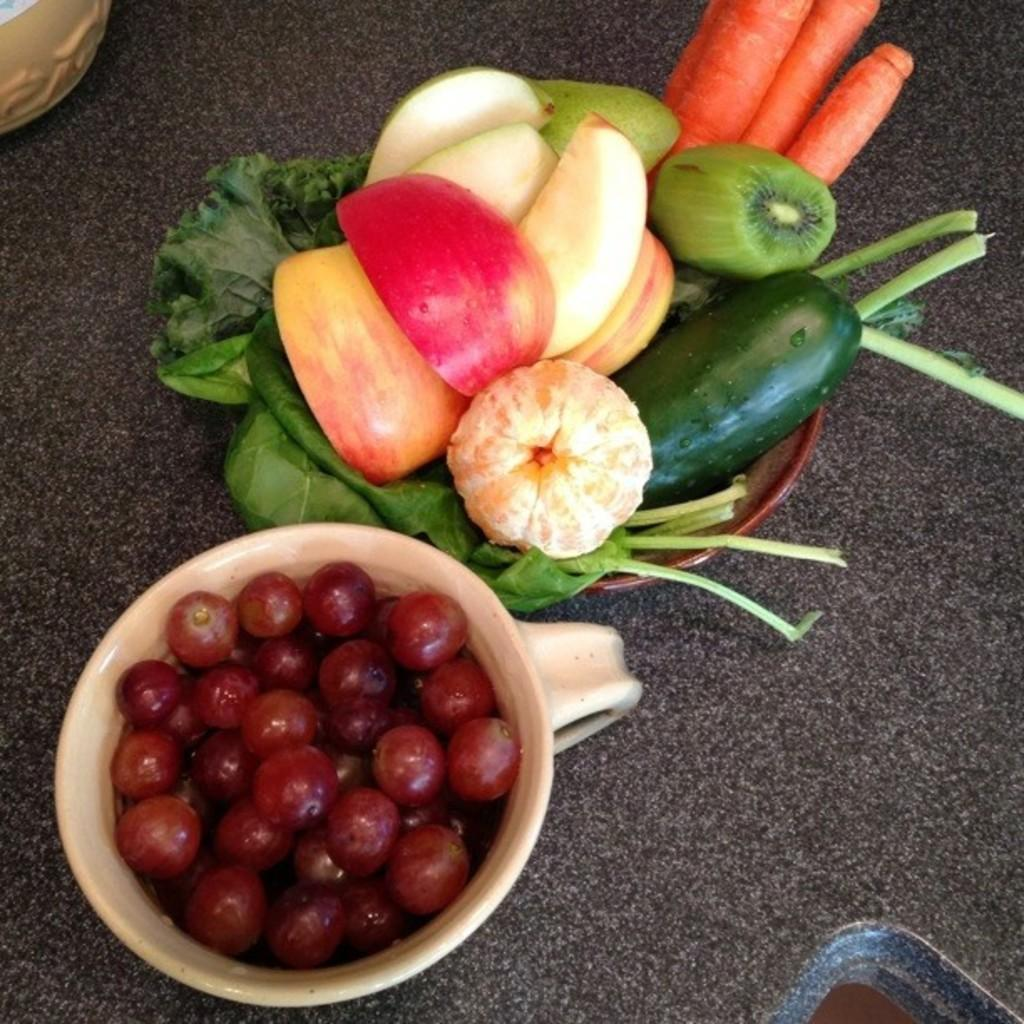What is on the countertop in the image? There is a bowl and a cup on the countertop in the image. What is inside the bowl? The bowl contains leaves and fruits. What is inside the cup? The cup contains grapes. Where is the crown placed in the image? There is no crown present in the image. Can you tell me how many potatoes are in the bowl? There are no potatoes in the image; the bowl contains leaves and fruits. 